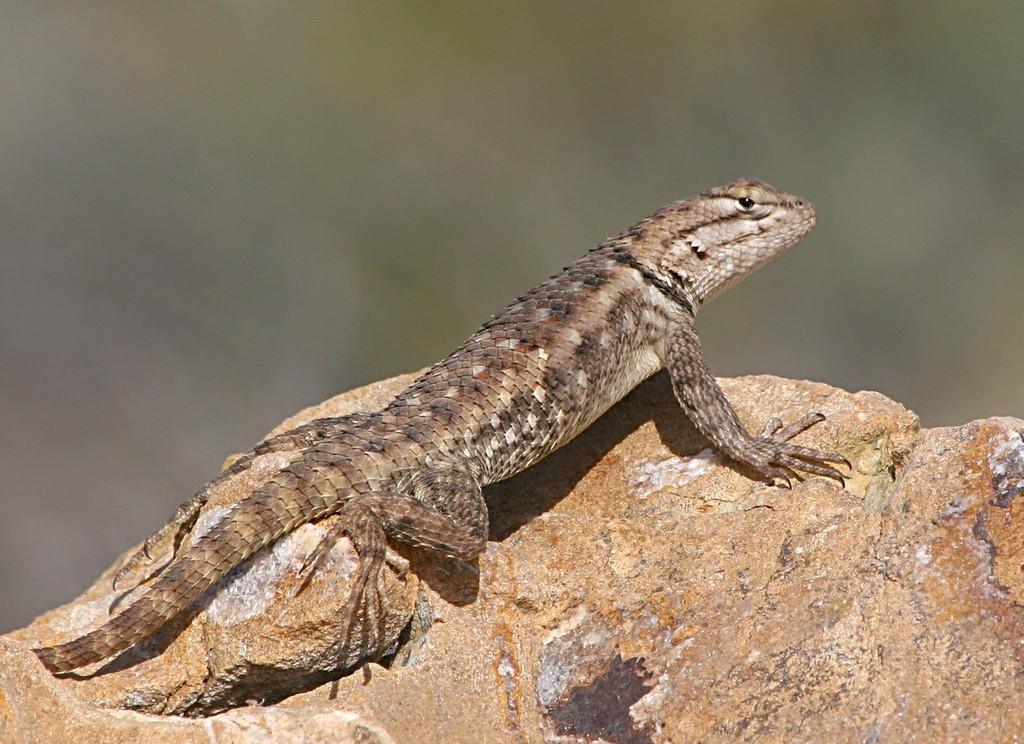Please provide a concise description of this image. In this image we can see a lizard on the rock. There is a blur background. 